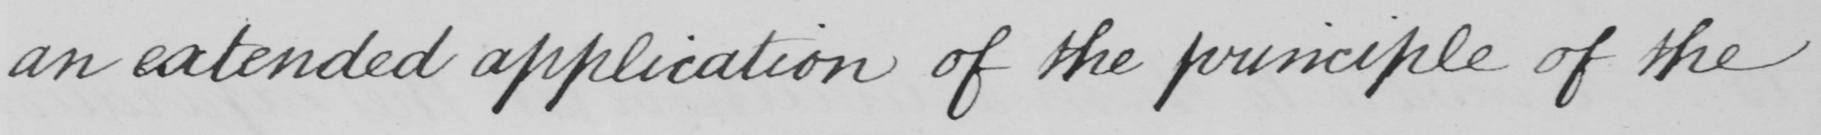What is written in this line of handwriting? an extended application of the principle of the 